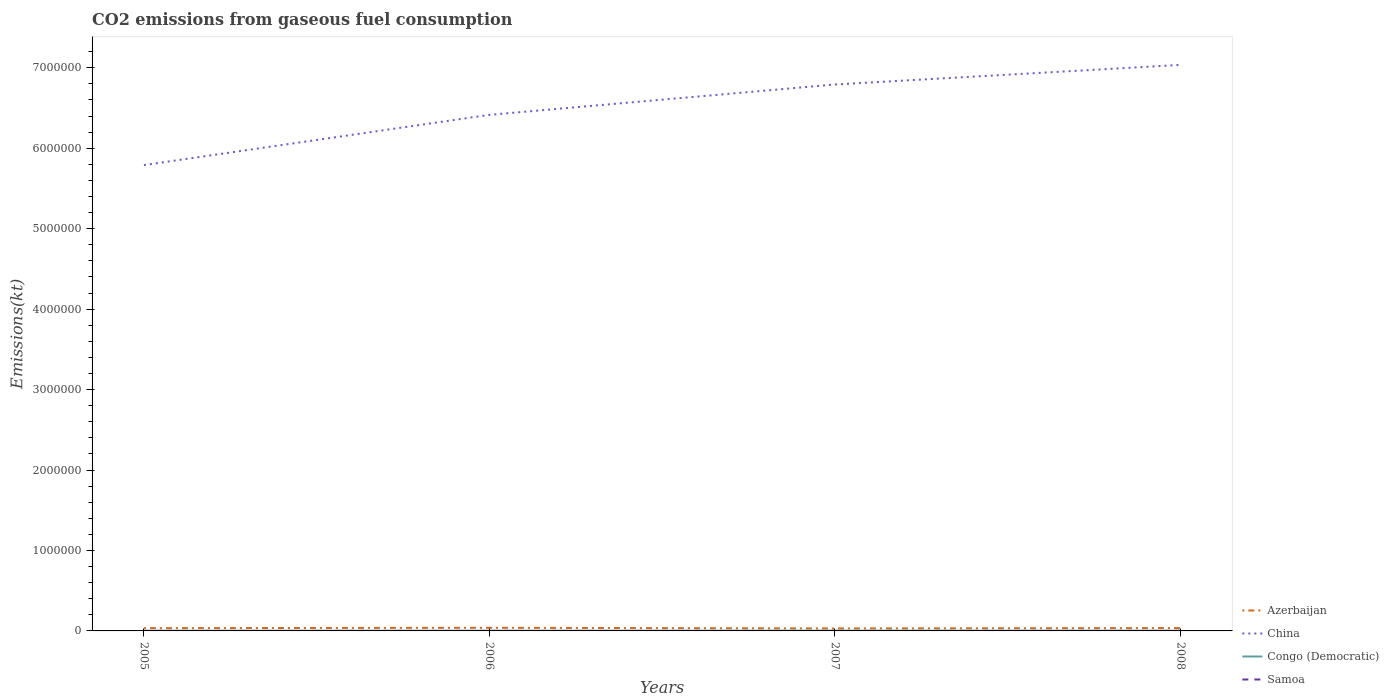Across all years, what is the maximum amount of CO2 emitted in Azerbaijan?
Keep it short and to the point. 3.05e+04. In which year was the amount of CO2 emitted in China maximum?
Provide a succinct answer. 2005. What is the total amount of CO2 emitted in China in the graph?
Ensure brevity in your answer.  -6.24e+05. What is the difference between the highest and the second highest amount of CO2 emitted in China?
Provide a succinct answer. 1.25e+06. Is the amount of CO2 emitted in Samoa strictly greater than the amount of CO2 emitted in Azerbaijan over the years?
Your answer should be compact. Yes. Does the graph contain any zero values?
Your answer should be very brief. No. Does the graph contain grids?
Ensure brevity in your answer.  No. How are the legend labels stacked?
Offer a very short reply. Vertical. What is the title of the graph?
Give a very brief answer. CO2 emissions from gaseous fuel consumption. Does "Maldives" appear as one of the legend labels in the graph?
Give a very brief answer. No. What is the label or title of the X-axis?
Give a very brief answer. Years. What is the label or title of the Y-axis?
Offer a terse response. Emissions(kt). What is the Emissions(kt) of Azerbaijan in 2005?
Make the answer very short. 3.43e+04. What is the Emissions(kt) in China in 2005?
Offer a terse response. 5.79e+06. What is the Emissions(kt) of Congo (Democratic) in 2005?
Provide a short and direct response. 2486.23. What is the Emissions(kt) of Samoa in 2005?
Your response must be concise. 168.68. What is the Emissions(kt) in Azerbaijan in 2006?
Make the answer very short. 3.92e+04. What is the Emissions(kt) in China in 2006?
Your response must be concise. 6.41e+06. What is the Emissions(kt) in Congo (Democratic) in 2006?
Your answer should be very brief. 2640.24. What is the Emissions(kt) in Samoa in 2006?
Your answer should be very brief. 176.02. What is the Emissions(kt) of Azerbaijan in 2007?
Provide a succinct answer. 3.05e+04. What is the Emissions(kt) in China in 2007?
Provide a succinct answer. 6.79e+06. What is the Emissions(kt) in Congo (Democratic) in 2007?
Offer a terse response. 2830.92. What is the Emissions(kt) of Samoa in 2007?
Offer a terse response. 187.02. What is the Emissions(kt) in Azerbaijan in 2008?
Give a very brief answer. 3.55e+04. What is the Emissions(kt) of China in 2008?
Provide a succinct answer. 7.04e+06. What is the Emissions(kt) in Congo (Democratic) in 2008?
Offer a very short reply. 2992.27. What is the Emissions(kt) of Samoa in 2008?
Your response must be concise. 190.68. Across all years, what is the maximum Emissions(kt) of Azerbaijan?
Provide a short and direct response. 3.92e+04. Across all years, what is the maximum Emissions(kt) in China?
Your response must be concise. 7.04e+06. Across all years, what is the maximum Emissions(kt) of Congo (Democratic)?
Your answer should be very brief. 2992.27. Across all years, what is the maximum Emissions(kt) in Samoa?
Provide a short and direct response. 190.68. Across all years, what is the minimum Emissions(kt) of Azerbaijan?
Keep it short and to the point. 3.05e+04. Across all years, what is the minimum Emissions(kt) in China?
Make the answer very short. 5.79e+06. Across all years, what is the minimum Emissions(kt) in Congo (Democratic)?
Keep it short and to the point. 2486.23. Across all years, what is the minimum Emissions(kt) in Samoa?
Your response must be concise. 168.68. What is the total Emissions(kt) in Azerbaijan in the graph?
Your response must be concise. 1.40e+05. What is the total Emissions(kt) in China in the graph?
Your answer should be very brief. 2.60e+07. What is the total Emissions(kt) in Congo (Democratic) in the graph?
Your answer should be compact. 1.09e+04. What is the total Emissions(kt) in Samoa in the graph?
Provide a short and direct response. 722.4. What is the difference between the Emissions(kt) in Azerbaijan in 2005 and that in 2006?
Your answer should be very brief. -4829.44. What is the difference between the Emissions(kt) in China in 2005 and that in 2006?
Make the answer very short. -6.24e+05. What is the difference between the Emissions(kt) in Congo (Democratic) in 2005 and that in 2006?
Ensure brevity in your answer.  -154.01. What is the difference between the Emissions(kt) of Samoa in 2005 and that in 2006?
Keep it short and to the point. -7.33. What is the difference between the Emissions(kt) in Azerbaijan in 2005 and that in 2007?
Provide a short and direct response. 3828.35. What is the difference between the Emissions(kt) in China in 2005 and that in 2007?
Give a very brief answer. -1.00e+06. What is the difference between the Emissions(kt) in Congo (Democratic) in 2005 and that in 2007?
Your answer should be compact. -344.7. What is the difference between the Emissions(kt) of Samoa in 2005 and that in 2007?
Give a very brief answer. -18.34. What is the difference between the Emissions(kt) of Azerbaijan in 2005 and that in 2008?
Ensure brevity in your answer.  -1166.11. What is the difference between the Emissions(kt) of China in 2005 and that in 2008?
Make the answer very short. -1.25e+06. What is the difference between the Emissions(kt) in Congo (Democratic) in 2005 and that in 2008?
Provide a short and direct response. -506.05. What is the difference between the Emissions(kt) in Samoa in 2005 and that in 2008?
Your answer should be very brief. -22. What is the difference between the Emissions(kt) in Azerbaijan in 2006 and that in 2007?
Provide a short and direct response. 8657.79. What is the difference between the Emissions(kt) of China in 2006 and that in 2007?
Keep it short and to the point. -3.77e+05. What is the difference between the Emissions(kt) in Congo (Democratic) in 2006 and that in 2007?
Your answer should be very brief. -190.68. What is the difference between the Emissions(kt) in Samoa in 2006 and that in 2007?
Provide a short and direct response. -11. What is the difference between the Emissions(kt) of Azerbaijan in 2006 and that in 2008?
Your response must be concise. 3663.33. What is the difference between the Emissions(kt) of China in 2006 and that in 2008?
Ensure brevity in your answer.  -6.21e+05. What is the difference between the Emissions(kt) in Congo (Democratic) in 2006 and that in 2008?
Ensure brevity in your answer.  -352.03. What is the difference between the Emissions(kt) of Samoa in 2006 and that in 2008?
Offer a very short reply. -14.67. What is the difference between the Emissions(kt) of Azerbaijan in 2007 and that in 2008?
Offer a terse response. -4994.45. What is the difference between the Emissions(kt) in China in 2007 and that in 2008?
Offer a terse response. -2.44e+05. What is the difference between the Emissions(kt) of Congo (Democratic) in 2007 and that in 2008?
Offer a very short reply. -161.35. What is the difference between the Emissions(kt) in Samoa in 2007 and that in 2008?
Offer a terse response. -3.67. What is the difference between the Emissions(kt) in Azerbaijan in 2005 and the Emissions(kt) in China in 2006?
Your answer should be compact. -6.38e+06. What is the difference between the Emissions(kt) in Azerbaijan in 2005 and the Emissions(kt) in Congo (Democratic) in 2006?
Provide a short and direct response. 3.17e+04. What is the difference between the Emissions(kt) in Azerbaijan in 2005 and the Emissions(kt) in Samoa in 2006?
Your answer should be very brief. 3.42e+04. What is the difference between the Emissions(kt) of China in 2005 and the Emissions(kt) of Congo (Democratic) in 2006?
Keep it short and to the point. 5.79e+06. What is the difference between the Emissions(kt) of China in 2005 and the Emissions(kt) of Samoa in 2006?
Your answer should be compact. 5.79e+06. What is the difference between the Emissions(kt) of Congo (Democratic) in 2005 and the Emissions(kt) of Samoa in 2006?
Make the answer very short. 2310.21. What is the difference between the Emissions(kt) in Azerbaijan in 2005 and the Emissions(kt) in China in 2007?
Your answer should be compact. -6.76e+06. What is the difference between the Emissions(kt) in Azerbaijan in 2005 and the Emissions(kt) in Congo (Democratic) in 2007?
Offer a very short reply. 3.15e+04. What is the difference between the Emissions(kt) in Azerbaijan in 2005 and the Emissions(kt) in Samoa in 2007?
Make the answer very short. 3.42e+04. What is the difference between the Emissions(kt) of China in 2005 and the Emissions(kt) of Congo (Democratic) in 2007?
Offer a very short reply. 5.79e+06. What is the difference between the Emissions(kt) of China in 2005 and the Emissions(kt) of Samoa in 2007?
Your response must be concise. 5.79e+06. What is the difference between the Emissions(kt) in Congo (Democratic) in 2005 and the Emissions(kt) in Samoa in 2007?
Provide a short and direct response. 2299.21. What is the difference between the Emissions(kt) of Azerbaijan in 2005 and the Emissions(kt) of China in 2008?
Make the answer very short. -7.00e+06. What is the difference between the Emissions(kt) in Azerbaijan in 2005 and the Emissions(kt) in Congo (Democratic) in 2008?
Keep it short and to the point. 3.13e+04. What is the difference between the Emissions(kt) in Azerbaijan in 2005 and the Emissions(kt) in Samoa in 2008?
Provide a short and direct response. 3.41e+04. What is the difference between the Emissions(kt) of China in 2005 and the Emissions(kt) of Congo (Democratic) in 2008?
Provide a short and direct response. 5.79e+06. What is the difference between the Emissions(kt) of China in 2005 and the Emissions(kt) of Samoa in 2008?
Your response must be concise. 5.79e+06. What is the difference between the Emissions(kt) in Congo (Democratic) in 2005 and the Emissions(kt) in Samoa in 2008?
Offer a terse response. 2295.54. What is the difference between the Emissions(kt) in Azerbaijan in 2006 and the Emissions(kt) in China in 2007?
Keep it short and to the point. -6.75e+06. What is the difference between the Emissions(kt) in Azerbaijan in 2006 and the Emissions(kt) in Congo (Democratic) in 2007?
Make the answer very short. 3.63e+04. What is the difference between the Emissions(kt) of Azerbaijan in 2006 and the Emissions(kt) of Samoa in 2007?
Keep it short and to the point. 3.90e+04. What is the difference between the Emissions(kt) of China in 2006 and the Emissions(kt) of Congo (Democratic) in 2007?
Ensure brevity in your answer.  6.41e+06. What is the difference between the Emissions(kt) of China in 2006 and the Emissions(kt) of Samoa in 2007?
Provide a succinct answer. 6.41e+06. What is the difference between the Emissions(kt) in Congo (Democratic) in 2006 and the Emissions(kt) in Samoa in 2007?
Provide a short and direct response. 2453.22. What is the difference between the Emissions(kt) in Azerbaijan in 2006 and the Emissions(kt) in China in 2008?
Provide a short and direct response. -7.00e+06. What is the difference between the Emissions(kt) in Azerbaijan in 2006 and the Emissions(kt) in Congo (Democratic) in 2008?
Give a very brief answer. 3.62e+04. What is the difference between the Emissions(kt) in Azerbaijan in 2006 and the Emissions(kt) in Samoa in 2008?
Offer a terse response. 3.90e+04. What is the difference between the Emissions(kt) in China in 2006 and the Emissions(kt) in Congo (Democratic) in 2008?
Make the answer very short. 6.41e+06. What is the difference between the Emissions(kt) of China in 2006 and the Emissions(kt) of Samoa in 2008?
Keep it short and to the point. 6.41e+06. What is the difference between the Emissions(kt) of Congo (Democratic) in 2006 and the Emissions(kt) of Samoa in 2008?
Your answer should be compact. 2449.56. What is the difference between the Emissions(kt) in Azerbaijan in 2007 and the Emissions(kt) in China in 2008?
Provide a succinct answer. -7.00e+06. What is the difference between the Emissions(kt) in Azerbaijan in 2007 and the Emissions(kt) in Congo (Democratic) in 2008?
Provide a short and direct response. 2.75e+04. What is the difference between the Emissions(kt) of Azerbaijan in 2007 and the Emissions(kt) of Samoa in 2008?
Provide a short and direct response. 3.03e+04. What is the difference between the Emissions(kt) in China in 2007 and the Emissions(kt) in Congo (Democratic) in 2008?
Your answer should be very brief. 6.79e+06. What is the difference between the Emissions(kt) in China in 2007 and the Emissions(kt) in Samoa in 2008?
Provide a succinct answer. 6.79e+06. What is the difference between the Emissions(kt) in Congo (Democratic) in 2007 and the Emissions(kt) in Samoa in 2008?
Give a very brief answer. 2640.24. What is the average Emissions(kt) in Azerbaijan per year?
Provide a succinct answer. 3.49e+04. What is the average Emissions(kt) of China per year?
Your answer should be very brief. 6.51e+06. What is the average Emissions(kt) in Congo (Democratic) per year?
Provide a succinct answer. 2737.42. What is the average Emissions(kt) in Samoa per year?
Keep it short and to the point. 180.6. In the year 2005, what is the difference between the Emissions(kt) of Azerbaijan and Emissions(kt) of China?
Make the answer very short. -5.76e+06. In the year 2005, what is the difference between the Emissions(kt) of Azerbaijan and Emissions(kt) of Congo (Democratic)?
Your response must be concise. 3.19e+04. In the year 2005, what is the difference between the Emissions(kt) in Azerbaijan and Emissions(kt) in Samoa?
Offer a very short reply. 3.42e+04. In the year 2005, what is the difference between the Emissions(kt) in China and Emissions(kt) in Congo (Democratic)?
Provide a succinct answer. 5.79e+06. In the year 2005, what is the difference between the Emissions(kt) in China and Emissions(kt) in Samoa?
Ensure brevity in your answer.  5.79e+06. In the year 2005, what is the difference between the Emissions(kt) of Congo (Democratic) and Emissions(kt) of Samoa?
Offer a terse response. 2317.54. In the year 2006, what is the difference between the Emissions(kt) of Azerbaijan and Emissions(kt) of China?
Make the answer very short. -6.38e+06. In the year 2006, what is the difference between the Emissions(kt) in Azerbaijan and Emissions(kt) in Congo (Democratic)?
Offer a very short reply. 3.65e+04. In the year 2006, what is the difference between the Emissions(kt) in Azerbaijan and Emissions(kt) in Samoa?
Provide a succinct answer. 3.90e+04. In the year 2006, what is the difference between the Emissions(kt) of China and Emissions(kt) of Congo (Democratic)?
Provide a short and direct response. 6.41e+06. In the year 2006, what is the difference between the Emissions(kt) of China and Emissions(kt) of Samoa?
Your answer should be compact. 6.41e+06. In the year 2006, what is the difference between the Emissions(kt) of Congo (Democratic) and Emissions(kt) of Samoa?
Your answer should be very brief. 2464.22. In the year 2007, what is the difference between the Emissions(kt) of Azerbaijan and Emissions(kt) of China?
Provide a succinct answer. -6.76e+06. In the year 2007, what is the difference between the Emissions(kt) of Azerbaijan and Emissions(kt) of Congo (Democratic)?
Make the answer very short. 2.77e+04. In the year 2007, what is the difference between the Emissions(kt) in Azerbaijan and Emissions(kt) in Samoa?
Keep it short and to the point. 3.03e+04. In the year 2007, what is the difference between the Emissions(kt) in China and Emissions(kt) in Congo (Democratic)?
Ensure brevity in your answer.  6.79e+06. In the year 2007, what is the difference between the Emissions(kt) in China and Emissions(kt) in Samoa?
Your answer should be compact. 6.79e+06. In the year 2007, what is the difference between the Emissions(kt) in Congo (Democratic) and Emissions(kt) in Samoa?
Make the answer very short. 2643.91. In the year 2008, what is the difference between the Emissions(kt) in Azerbaijan and Emissions(kt) in China?
Make the answer very short. -7.00e+06. In the year 2008, what is the difference between the Emissions(kt) in Azerbaijan and Emissions(kt) in Congo (Democratic)?
Provide a short and direct response. 3.25e+04. In the year 2008, what is the difference between the Emissions(kt) in Azerbaijan and Emissions(kt) in Samoa?
Offer a terse response. 3.53e+04. In the year 2008, what is the difference between the Emissions(kt) of China and Emissions(kt) of Congo (Democratic)?
Your response must be concise. 7.03e+06. In the year 2008, what is the difference between the Emissions(kt) in China and Emissions(kt) in Samoa?
Your response must be concise. 7.04e+06. In the year 2008, what is the difference between the Emissions(kt) in Congo (Democratic) and Emissions(kt) in Samoa?
Make the answer very short. 2801.59. What is the ratio of the Emissions(kt) in Azerbaijan in 2005 to that in 2006?
Make the answer very short. 0.88. What is the ratio of the Emissions(kt) in China in 2005 to that in 2006?
Offer a very short reply. 0.9. What is the ratio of the Emissions(kt) in Congo (Democratic) in 2005 to that in 2006?
Provide a succinct answer. 0.94. What is the ratio of the Emissions(kt) in Samoa in 2005 to that in 2006?
Provide a succinct answer. 0.96. What is the ratio of the Emissions(kt) in Azerbaijan in 2005 to that in 2007?
Make the answer very short. 1.13. What is the ratio of the Emissions(kt) in China in 2005 to that in 2007?
Your response must be concise. 0.85. What is the ratio of the Emissions(kt) in Congo (Democratic) in 2005 to that in 2007?
Your answer should be very brief. 0.88. What is the ratio of the Emissions(kt) in Samoa in 2005 to that in 2007?
Your response must be concise. 0.9. What is the ratio of the Emissions(kt) in Azerbaijan in 2005 to that in 2008?
Your answer should be very brief. 0.97. What is the ratio of the Emissions(kt) in China in 2005 to that in 2008?
Keep it short and to the point. 0.82. What is the ratio of the Emissions(kt) of Congo (Democratic) in 2005 to that in 2008?
Keep it short and to the point. 0.83. What is the ratio of the Emissions(kt) in Samoa in 2005 to that in 2008?
Make the answer very short. 0.88. What is the ratio of the Emissions(kt) in Azerbaijan in 2006 to that in 2007?
Ensure brevity in your answer.  1.28. What is the ratio of the Emissions(kt) of Congo (Democratic) in 2006 to that in 2007?
Your answer should be very brief. 0.93. What is the ratio of the Emissions(kt) in Azerbaijan in 2006 to that in 2008?
Make the answer very short. 1.1. What is the ratio of the Emissions(kt) of China in 2006 to that in 2008?
Give a very brief answer. 0.91. What is the ratio of the Emissions(kt) in Congo (Democratic) in 2006 to that in 2008?
Your answer should be compact. 0.88. What is the ratio of the Emissions(kt) in Azerbaijan in 2007 to that in 2008?
Offer a terse response. 0.86. What is the ratio of the Emissions(kt) of China in 2007 to that in 2008?
Make the answer very short. 0.97. What is the ratio of the Emissions(kt) in Congo (Democratic) in 2007 to that in 2008?
Your response must be concise. 0.95. What is the ratio of the Emissions(kt) of Samoa in 2007 to that in 2008?
Keep it short and to the point. 0.98. What is the difference between the highest and the second highest Emissions(kt) of Azerbaijan?
Keep it short and to the point. 3663.33. What is the difference between the highest and the second highest Emissions(kt) in China?
Your answer should be compact. 2.44e+05. What is the difference between the highest and the second highest Emissions(kt) in Congo (Democratic)?
Keep it short and to the point. 161.35. What is the difference between the highest and the second highest Emissions(kt) of Samoa?
Give a very brief answer. 3.67. What is the difference between the highest and the lowest Emissions(kt) in Azerbaijan?
Provide a short and direct response. 8657.79. What is the difference between the highest and the lowest Emissions(kt) of China?
Your answer should be compact. 1.25e+06. What is the difference between the highest and the lowest Emissions(kt) of Congo (Democratic)?
Your answer should be very brief. 506.05. What is the difference between the highest and the lowest Emissions(kt) in Samoa?
Ensure brevity in your answer.  22. 